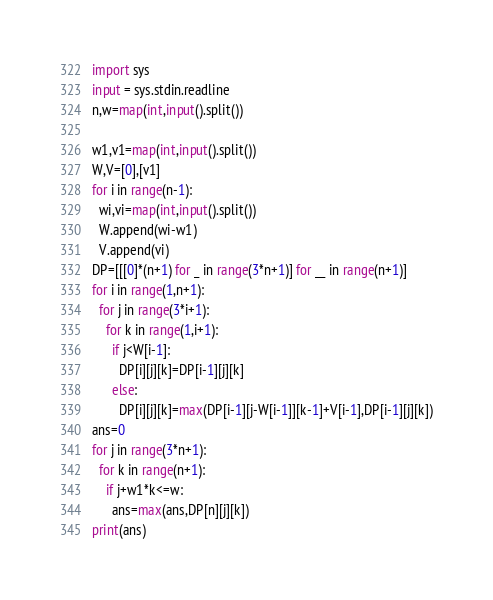<code> <loc_0><loc_0><loc_500><loc_500><_Python_>import sys
input = sys.stdin.readline
n,w=map(int,input().split())

w1,v1=map(int,input().split())
W,V=[0],[v1]
for i in range(n-1):
  wi,vi=map(int,input().split())
  W.append(wi-w1)
  V.append(vi)
DP=[[[0]*(n+1) for _ in range(3*n+1)] for __ in range(n+1)]
for i in range(1,n+1):
  for j in range(3*i+1):
    for k in range(1,i+1):
      if j<W[i-1]:
        DP[i][j][k]=DP[i-1][j][k]
      else:
        DP[i][j][k]=max(DP[i-1][j-W[i-1]][k-1]+V[i-1],DP[i-1][j][k])
ans=0
for j in range(3*n+1):
  for k in range(n+1):
    if j+w1*k<=w:
      ans=max(ans,DP[n][j][k])
print(ans)</code> 